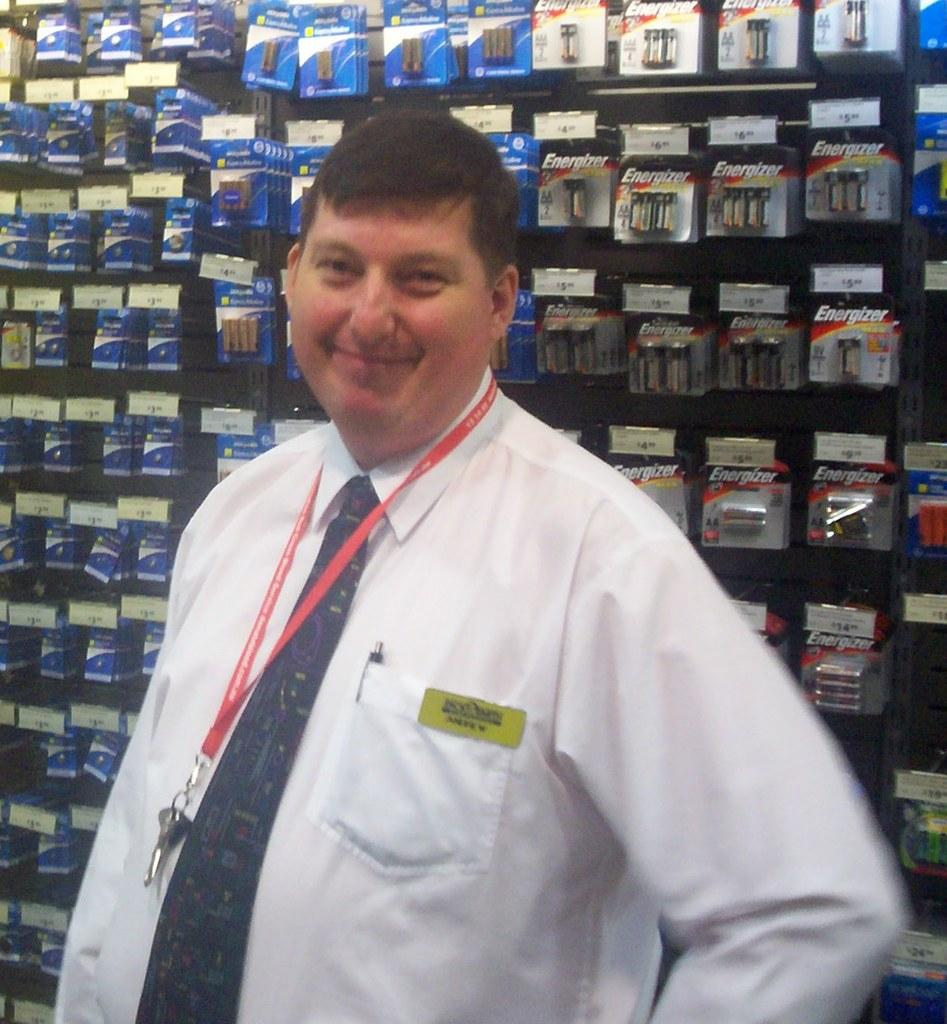<image>
Create a compact narrative representing the image presented. man with nametag Andrew standing in front of wall of batteries including energizer brand 